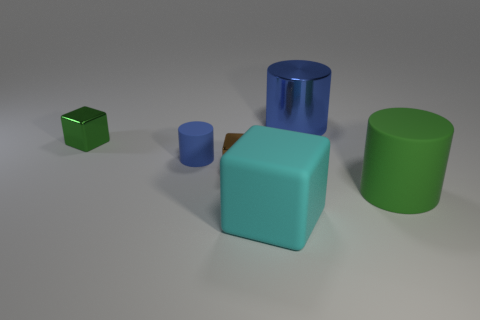Is the number of small brown shiny cubes that are right of the cyan thing less than the number of large metal cylinders?
Provide a short and direct response. Yes. Does the small cylinder have the same color as the big metallic thing?
Provide a short and direct response. Yes. How big is the cyan object?
Your answer should be compact. Large. How many metal blocks have the same color as the large shiny cylinder?
Your answer should be compact. 0. Is there a large cylinder in front of the tiny metallic thing right of the cube that is behind the tiny blue object?
Keep it short and to the point. Yes. The cyan thing that is the same size as the shiny cylinder is what shape?
Give a very brief answer. Cube. How many small things are green metallic things or blue rubber cylinders?
Keep it short and to the point. 2. There is a tiny cylinder that is the same material as the large cyan block; what is its color?
Keep it short and to the point. Blue. Do the green thing on the right side of the blue rubber object and the shiny object in front of the tiny green metal block have the same shape?
Keep it short and to the point. No. What number of shiny objects are either green cylinders or green balls?
Ensure brevity in your answer.  0. 